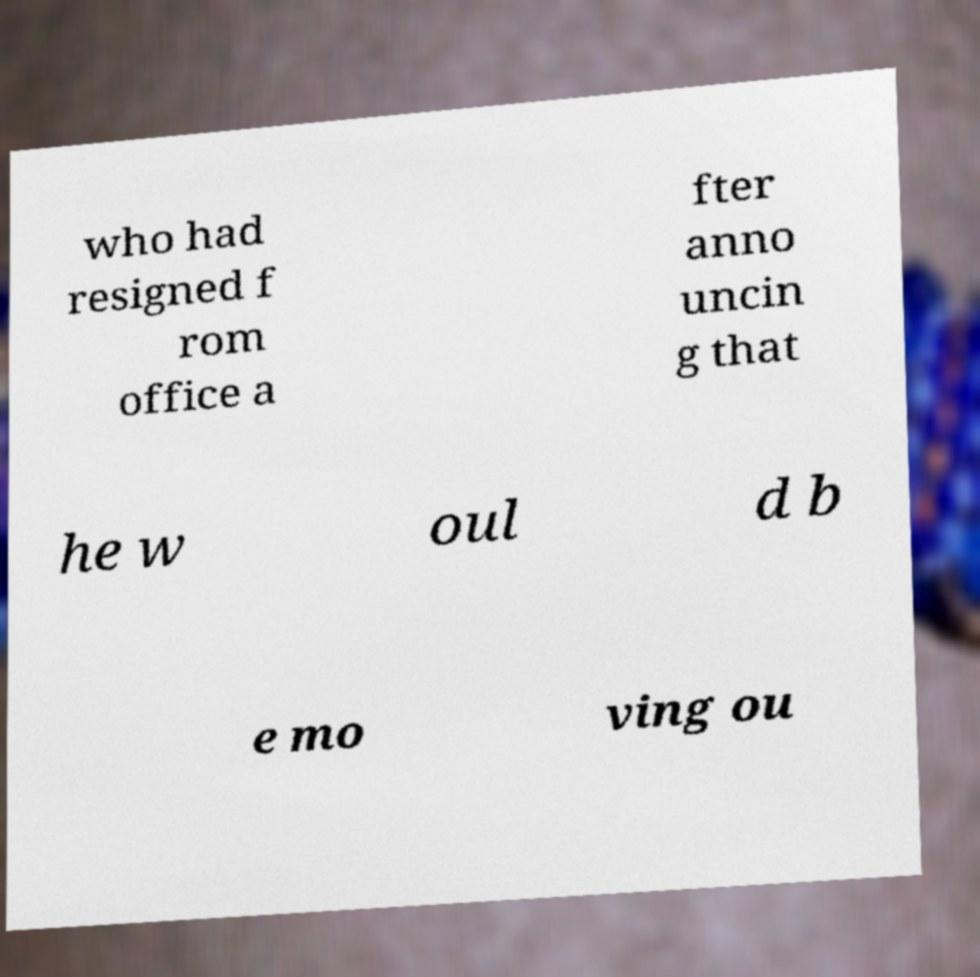I need the written content from this picture converted into text. Can you do that? who had resigned f rom office a fter anno uncin g that he w oul d b e mo ving ou 